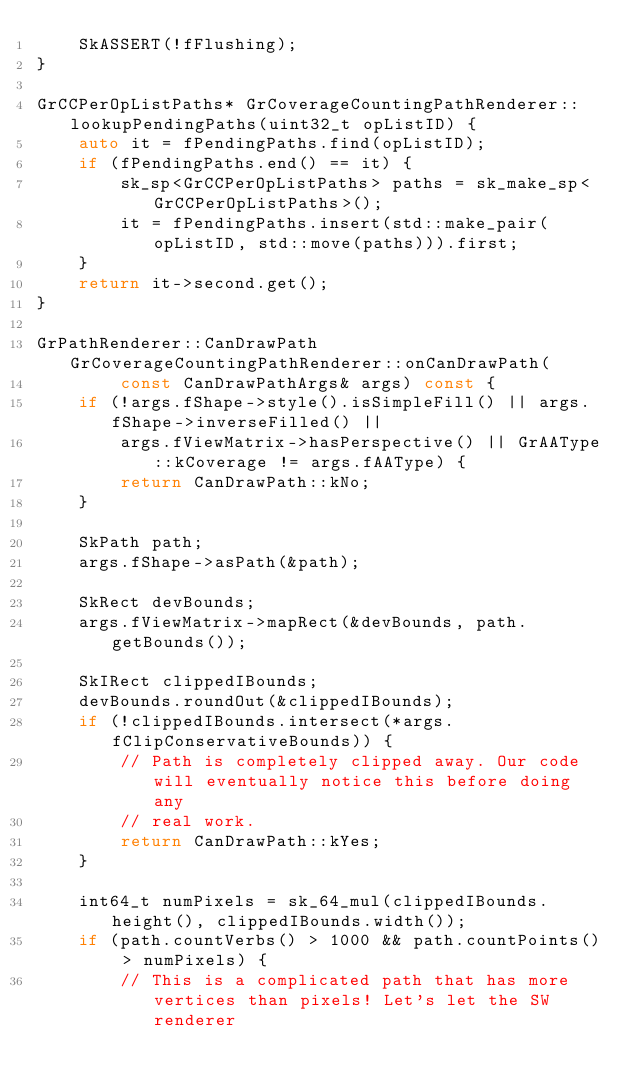<code> <loc_0><loc_0><loc_500><loc_500><_C++_>    SkASSERT(!fFlushing);
}

GrCCPerOpListPaths* GrCoverageCountingPathRenderer::lookupPendingPaths(uint32_t opListID) {
    auto it = fPendingPaths.find(opListID);
    if (fPendingPaths.end() == it) {
        sk_sp<GrCCPerOpListPaths> paths = sk_make_sp<GrCCPerOpListPaths>();
        it = fPendingPaths.insert(std::make_pair(opListID, std::move(paths))).first;
    }
    return it->second.get();
}

GrPathRenderer::CanDrawPath GrCoverageCountingPathRenderer::onCanDrawPath(
        const CanDrawPathArgs& args) const {
    if (!args.fShape->style().isSimpleFill() || args.fShape->inverseFilled() ||
        args.fViewMatrix->hasPerspective() || GrAAType::kCoverage != args.fAAType) {
        return CanDrawPath::kNo;
    }

    SkPath path;
    args.fShape->asPath(&path);

    SkRect devBounds;
    args.fViewMatrix->mapRect(&devBounds, path.getBounds());

    SkIRect clippedIBounds;
    devBounds.roundOut(&clippedIBounds);
    if (!clippedIBounds.intersect(*args.fClipConservativeBounds)) {
        // Path is completely clipped away. Our code will eventually notice this before doing any
        // real work.
        return CanDrawPath::kYes;
    }

    int64_t numPixels = sk_64_mul(clippedIBounds.height(), clippedIBounds.width());
    if (path.countVerbs() > 1000 && path.countPoints() > numPixels) {
        // This is a complicated path that has more vertices than pixels! Let's let the SW renderer</code> 